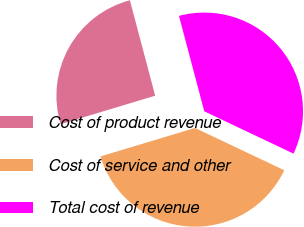Convert chart. <chart><loc_0><loc_0><loc_500><loc_500><pie_chart><fcel>Cost of product revenue<fcel>Cost of service and other<fcel>Total cost of revenue<nl><fcel>25.53%<fcel>38.3%<fcel>36.17%<nl></chart> 